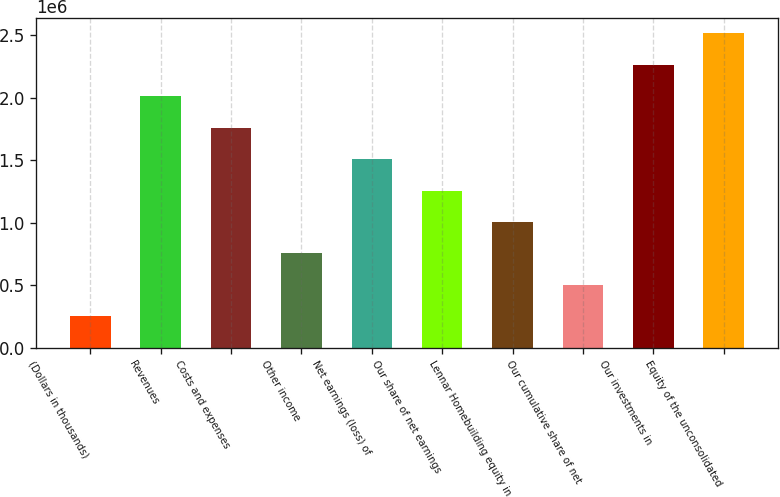<chart> <loc_0><loc_0><loc_500><loc_500><bar_chart><fcel>(Dollars in thousands)<fcel>Revenues<fcel>Costs and expenses<fcel>Other income<fcel>Net earnings (loss) of<fcel>Our share of net earnings<fcel>Lennar Homebuilding equity in<fcel>Our cumulative share of net<fcel>Our investments in<fcel>Equity of the unconsolidated<nl><fcel>251359<fcel>2.01067e+06<fcel>1.75934e+06<fcel>754019<fcel>1.50801e+06<fcel>1.25668e+06<fcel>1.00535e+06<fcel>502689<fcel>2.262e+06<fcel>2.51333e+06<nl></chart> 